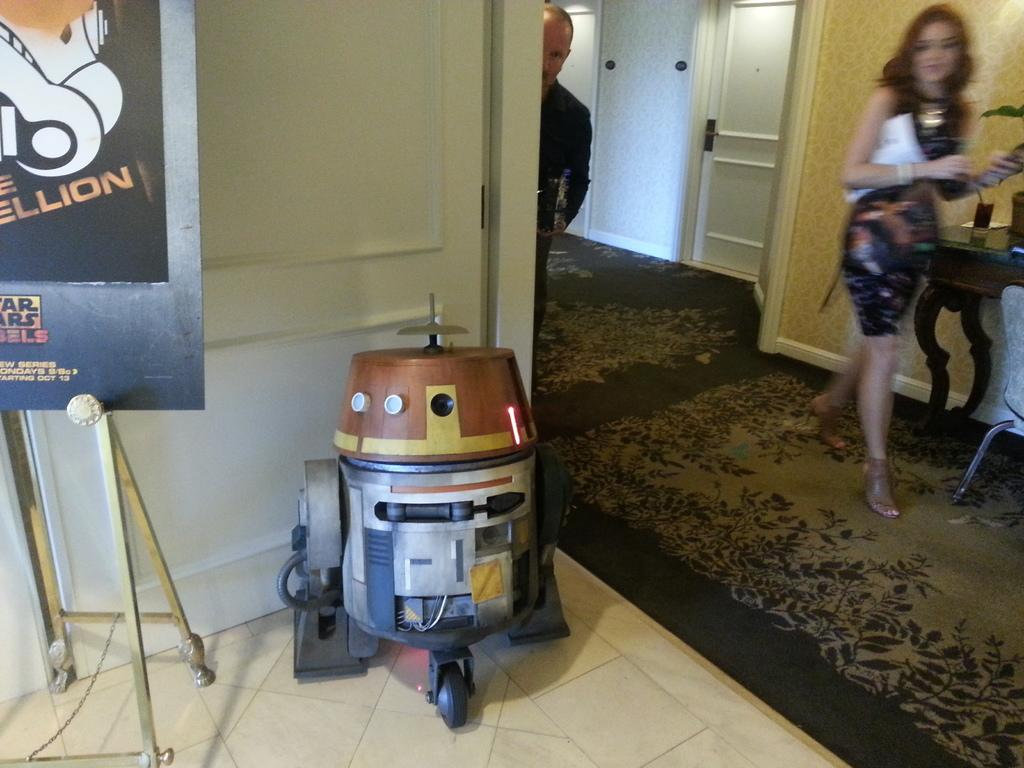<image>
Give a short and clear explanation of the subsequent image. a little robot next to a star wars sign 